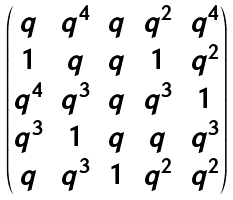<formula> <loc_0><loc_0><loc_500><loc_500>\begin{pmatrix} q & q ^ { 4 } & q & q ^ { 2 } & q ^ { 4 } \\ 1 & q & q & 1 & q ^ { 2 } \\ q ^ { 4 } & q ^ { 3 } & q & q ^ { 3 } & 1 \\ q ^ { 3 } & 1 & q & q & q ^ { 3 } \\ q & q ^ { 3 } & 1 & q ^ { 2 } & q ^ { 2 } \\ \end{pmatrix}</formula> 